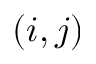Convert formula to latex. <formula><loc_0><loc_0><loc_500><loc_500>( i , j )</formula> 